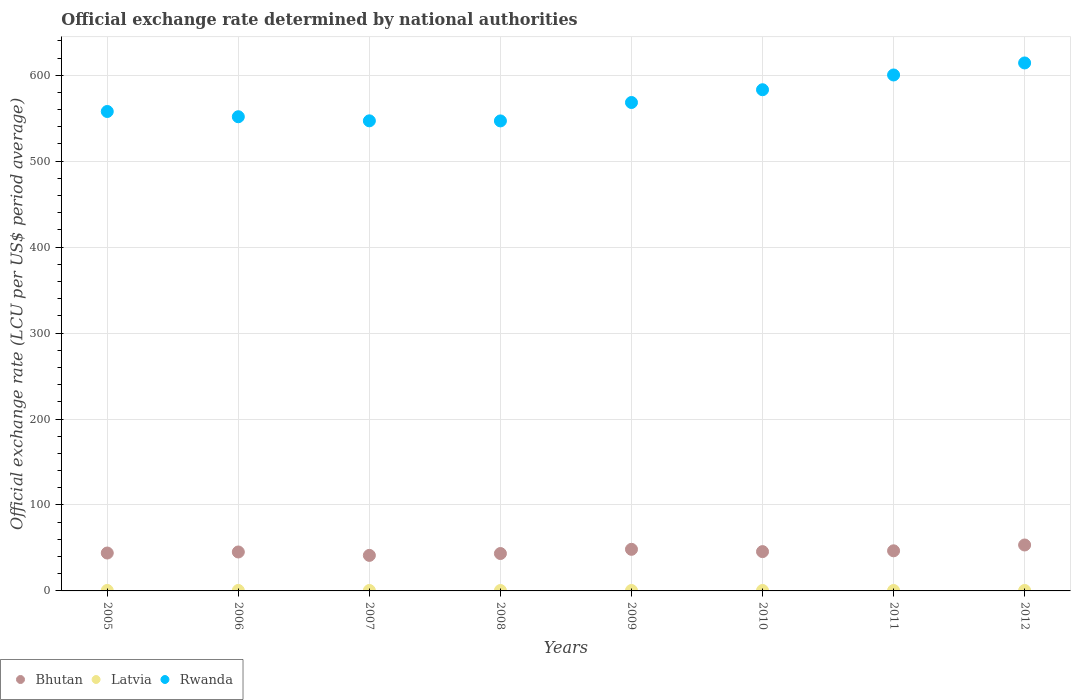How many different coloured dotlines are there?
Give a very brief answer. 3. Is the number of dotlines equal to the number of legend labels?
Ensure brevity in your answer.  Yes. What is the official exchange rate in Bhutan in 2007?
Your response must be concise. 41.35. Across all years, what is the maximum official exchange rate in Bhutan?
Offer a very short reply. 53.44. Across all years, what is the minimum official exchange rate in Rwanda?
Offer a terse response. 546.85. In which year was the official exchange rate in Rwanda minimum?
Keep it short and to the point. 2008. What is the total official exchange rate in Rwanda in the graph?
Provide a succinct answer. 4569.35. What is the difference between the official exchange rate in Rwanda in 2006 and that in 2009?
Provide a short and direct response. -16.57. What is the difference between the official exchange rate in Rwanda in 2011 and the official exchange rate in Latvia in 2012?
Offer a terse response. 599.76. What is the average official exchange rate in Bhutan per year?
Keep it short and to the point. 46.06. In the year 2008, what is the difference between the official exchange rate in Bhutan and official exchange rate in Latvia?
Your response must be concise. 43.02. In how many years, is the official exchange rate in Bhutan greater than 380 LCU?
Offer a very short reply. 0. What is the ratio of the official exchange rate in Latvia in 2005 to that in 2008?
Offer a terse response. 1.17. What is the difference between the highest and the second highest official exchange rate in Latvia?
Your response must be concise. 0. What is the difference between the highest and the lowest official exchange rate in Latvia?
Provide a succinct answer. 0.08. In how many years, is the official exchange rate in Bhutan greater than the average official exchange rate in Bhutan taken over all years?
Your answer should be compact. 3. Is the sum of the official exchange rate in Rwanda in 2008 and 2011 greater than the maximum official exchange rate in Bhutan across all years?
Give a very brief answer. Yes. Is it the case that in every year, the sum of the official exchange rate in Latvia and official exchange rate in Rwanda  is greater than the official exchange rate in Bhutan?
Make the answer very short. Yes. Does the official exchange rate in Rwanda monotonically increase over the years?
Provide a succinct answer. No. How many dotlines are there?
Provide a succinct answer. 3. How many years are there in the graph?
Give a very brief answer. 8. Are the values on the major ticks of Y-axis written in scientific E-notation?
Make the answer very short. No. Does the graph contain grids?
Your answer should be very brief. Yes. Where does the legend appear in the graph?
Provide a succinct answer. Bottom left. How are the legend labels stacked?
Your answer should be compact. Horizontal. What is the title of the graph?
Offer a terse response. Official exchange rate determined by national authorities. Does "Liberia" appear as one of the legend labels in the graph?
Make the answer very short. No. What is the label or title of the Y-axis?
Offer a terse response. Official exchange rate (LCU per US$ period average). What is the Official exchange rate (LCU per US$ period average) in Bhutan in 2005?
Provide a short and direct response. 44.1. What is the Official exchange rate (LCU per US$ period average) of Latvia in 2005?
Make the answer very short. 0.56. What is the Official exchange rate (LCU per US$ period average) of Rwanda in 2005?
Provide a succinct answer. 557.82. What is the Official exchange rate (LCU per US$ period average) in Bhutan in 2006?
Your answer should be very brief. 45.31. What is the Official exchange rate (LCU per US$ period average) of Latvia in 2006?
Make the answer very short. 0.56. What is the Official exchange rate (LCU per US$ period average) in Rwanda in 2006?
Ensure brevity in your answer.  551.71. What is the Official exchange rate (LCU per US$ period average) in Bhutan in 2007?
Offer a very short reply. 41.35. What is the Official exchange rate (LCU per US$ period average) of Latvia in 2007?
Offer a very short reply. 0.51. What is the Official exchange rate (LCU per US$ period average) of Rwanda in 2007?
Your answer should be very brief. 546.96. What is the Official exchange rate (LCU per US$ period average) in Bhutan in 2008?
Your answer should be compact. 43.51. What is the Official exchange rate (LCU per US$ period average) of Latvia in 2008?
Your answer should be very brief. 0.48. What is the Official exchange rate (LCU per US$ period average) in Rwanda in 2008?
Provide a succinct answer. 546.85. What is the Official exchange rate (LCU per US$ period average) of Bhutan in 2009?
Keep it short and to the point. 48.41. What is the Official exchange rate (LCU per US$ period average) of Latvia in 2009?
Offer a very short reply. 0.51. What is the Official exchange rate (LCU per US$ period average) in Rwanda in 2009?
Your answer should be very brief. 568.28. What is the Official exchange rate (LCU per US$ period average) in Bhutan in 2010?
Your answer should be very brief. 45.73. What is the Official exchange rate (LCU per US$ period average) in Latvia in 2010?
Ensure brevity in your answer.  0.53. What is the Official exchange rate (LCU per US$ period average) in Rwanda in 2010?
Offer a very short reply. 583.13. What is the Official exchange rate (LCU per US$ period average) of Bhutan in 2011?
Ensure brevity in your answer.  46.67. What is the Official exchange rate (LCU per US$ period average) in Latvia in 2011?
Your response must be concise. 0.5. What is the Official exchange rate (LCU per US$ period average) in Rwanda in 2011?
Provide a short and direct response. 600.31. What is the Official exchange rate (LCU per US$ period average) of Bhutan in 2012?
Ensure brevity in your answer.  53.44. What is the Official exchange rate (LCU per US$ period average) of Latvia in 2012?
Offer a terse response. 0.55. What is the Official exchange rate (LCU per US$ period average) in Rwanda in 2012?
Your answer should be compact. 614.3. Across all years, what is the maximum Official exchange rate (LCU per US$ period average) in Bhutan?
Your response must be concise. 53.44. Across all years, what is the maximum Official exchange rate (LCU per US$ period average) in Latvia?
Keep it short and to the point. 0.56. Across all years, what is the maximum Official exchange rate (LCU per US$ period average) of Rwanda?
Ensure brevity in your answer.  614.3. Across all years, what is the minimum Official exchange rate (LCU per US$ period average) in Bhutan?
Offer a terse response. 41.35. Across all years, what is the minimum Official exchange rate (LCU per US$ period average) in Latvia?
Your answer should be compact. 0.48. Across all years, what is the minimum Official exchange rate (LCU per US$ period average) of Rwanda?
Keep it short and to the point. 546.85. What is the total Official exchange rate (LCU per US$ period average) of Bhutan in the graph?
Provide a succinct answer. 368.5. What is the total Official exchange rate (LCU per US$ period average) of Latvia in the graph?
Keep it short and to the point. 4.2. What is the total Official exchange rate (LCU per US$ period average) in Rwanda in the graph?
Make the answer very short. 4569.35. What is the difference between the Official exchange rate (LCU per US$ period average) in Bhutan in 2005 and that in 2006?
Your response must be concise. -1.21. What is the difference between the Official exchange rate (LCU per US$ period average) of Latvia in 2005 and that in 2006?
Provide a short and direct response. 0. What is the difference between the Official exchange rate (LCU per US$ period average) of Rwanda in 2005 and that in 2006?
Offer a terse response. 6.11. What is the difference between the Official exchange rate (LCU per US$ period average) in Bhutan in 2005 and that in 2007?
Ensure brevity in your answer.  2.75. What is the difference between the Official exchange rate (LCU per US$ period average) in Latvia in 2005 and that in 2007?
Your response must be concise. 0.05. What is the difference between the Official exchange rate (LCU per US$ period average) in Rwanda in 2005 and that in 2007?
Give a very brief answer. 10.87. What is the difference between the Official exchange rate (LCU per US$ period average) of Bhutan in 2005 and that in 2008?
Your response must be concise. 0.59. What is the difference between the Official exchange rate (LCU per US$ period average) of Latvia in 2005 and that in 2008?
Provide a short and direct response. 0.08. What is the difference between the Official exchange rate (LCU per US$ period average) of Rwanda in 2005 and that in 2008?
Make the answer very short. 10.97. What is the difference between the Official exchange rate (LCU per US$ period average) of Bhutan in 2005 and that in 2009?
Ensure brevity in your answer.  -4.31. What is the difference between the Official exchange rate (LCU per US$ period average) of Latvia in 2005 and that in 2009?
Give a very brief answer. 0.06. What is the difference between the Official exchange rate (LCU per US$ period average) of Rwanda in 2005 and that in 2009?
Give a very brief answer. -10.46. What is the difference between the Official exchange rate (LCU per US$ period average) of Bhutan in 2005 and that in 2010?
Offer a very short reply. -1.63. What is the difference between the Official exchange rate (LCU per US$ period average) in Latvia in 2005 and that in 2010?
Ensure brevity in your answer.  0.03. What is the difference between the Official exchange rate (LCU per US$ period average) in Rwanda in 2005 and that in 2010?
Give a very brief answer. -25.31. What is the difference between the Official exchange rate (LCU per US$ period average) in Bhutan in 2005 and that in 2011?
Provide a succinct answer. -2.57. What is the difference between the Official exchange rate (LCU per US$ period average) in Latvia in 2005 and that in 2011?
Provide a short and direct response. 0.06. What is the difference between the Official exchange rate (LCU per US$ period average) in Rwanda in 2005 and that in 2011?
Make the answer very short. -42.48. What is the difference between the Official exchange rate (LCU per US$ period average) in Bhutan in 2005 and that in 2012?
Offer a very short reply. -9.34. What is the difference between the Official exchange rate (LCU per US$ period average) of Latvia in 2005 and that in 2012?
Your answer should be very brief. 0.02. What is the difference between the Official exchange rate (LCU per US$ period average) in Rwanda in 2005 and that in 2012?
Keep it short and to the point. -56.47. What is the difference between the Official exchange rate (LCU per US$ period average) of Bhutan in 2006 and that in 2007?
Your answer should be very brief. 3.96. What is the difference between the Official exchange rate (LCU per US$ period average) in Latvia in 2006 and that in 2007?
Make the answer very short. 0.05. What is the difference between the Official exchange rate (LCU per US$ period average) in Rwanda in 2006 and that in 2007?
Your answer should be compact. 4.76. What is the difference between the Official exchange rate (LCU per US$ period average) in Bhutan in 2006 and that in 2008?
Your answer should be very brief. 1.8. What is the difference between the Official exchange rate (LCU per US$ period average) of Latvia in 2006 and that in 2008?
Provide a short and direct response. 0.08. What is the difference between the Official exchange rate (LCU per US$ period average) in Rwanda in 2006 and that in 2008?
Your answer should be very brief. 4.86. What is the difference between the Official exchange rate (LCU per US$ period average) in Bhutan in 2006 and that in 2009?
Provide a succinct answer. -3.1. What is the difference between the Official exchange rate (LCU per US$ period average) of Latvia in 2006 and that in 2009?
Make the answer very short. 0.05. What is the difference between the Official exchange rate (LCU per US$ period average) of Rwanda in 2006 and that in 2009?
Keep it short and to the point. -16.57. What is the difference between the Official exchange rate (LCU per US$ period average) in Bhutan in 2006 and that in 2010?
Offer a terse response. -0.42. What is the difference between the Official exchange rate (LCU per US$ period average) in Latvia in 2006 and that in 2010?
Your answer should be compact. 0.03. What is the difference between the Official exchange rate (LCU per US$ period average) in Rwanda in 2006 and that in 2010?
Give a very brief answer. -31.42. What is the difference between the Official exchange rate (LCU per US$ period average) in Bhutan in 2006 and that in 2011?
Your response must be concise. -1.36. What is the difference between the Official exchange rate (LCU per US$ period average) in Latvia in 2006 and that in 2011?
Keep it short and to the point. 0.06. What is the difference between the Official exchange rate (LCU per US$ period average) in Rwanda in 2006 and that in 2011?
Your response must be concise. -48.6. What is the difference between the Official exchange rate (LCU per US$ period average) in Bhutan in 2006 and that in 2012?
Make the answer very short. -8.13. What is the difference between the Official exchange rate (LCU per US$ period average) of Latvia in 2006 and that in 2012?
Offer a terse response. 0.01. What is the difference between the Official exchange rate (LCU per US$ period average) of Rwanda in 2006 and that in 2012?
Make the answer very short. -62.58. What is the difference between the Official exchange rate (LCU per US$ period average) in Bhutan in 2007 and that in 2008?
Your answer should be very brief. -2.16. What is the difference between the Official exchange rate (LCU per US$ period average) of Latvia in 2007 and that in 2008?
Offer a terse response. 0.03. What is the difference between the Official exchange rate (LCU per US$ period average) of Rwanda in 2007 and that in 2008?
Keep it short and to the point. 0.11. What is the difference between the Official exchange rate (LCU per US$ period average) in Bhutan in 2007 and that in 2009?
Ensure brevity in your answer.  -7.06. What is the difference between the Official exchange rate (LCU per US$ period average) of Latvia in 2007 and that in 2009?
Your answer should be very brief. 0.01. What is the difference between the Official exchange rate (LCU per US$ period average) of Rwanda in 2007 and that in 2009?
Your response must be concise. -21.33. What is the difference between the Official exchange rate (LCU per US$ period average) in Bhutan in 2007 and that in 2010?
Your answer should be compact. -4.38. What is the difference between the Official exchange rate (LCU per US$ period average) in Latvia in 2007 and that in 2010?
Offer a very short reply. -0.02. What is the difference between the Official exchange rate (LCU per US$ period average) in Rwanda in 2007 and that in 2010?
Keep it short and to the point. -36.18. What is the difference between the Official exchange rate (LCU per US$ period average) of Bhutan in 2007 and that in 2011?
Your answer should be compact. -5.32. What is the difference between the Official exchange rate (LCU per US$ period average) in Latvia in 2007 and that in 2011?
Make the answer very short. 0.01. What is the difference between the Official exchange rate (LCU per US$ period average) of Rwanda in 2007 and that in 2011?
Give a very brief answer. -53.35. What is the difference between the Official exchange rate (LCU per US$ period average) of Bhutan in 2007 and that in 2012?
Offer a terse response. -12.09. What is the difference between the Official exchange rate (LCU per US$ period average) in Latvia in 2007 and that in 2012?
Ensure brevity in your answer.  -0.03. What is the difference between the Official exchange rate (LCU per US$ period average) in Rwanda in 2007 and that in 2012?
Provide a short and direct response. -67.34. What is the difference between the Official exchange rate (LCU per US$ period average) in Bhutan in 2008 and that in 2009?
Give a very brief answer. -4.9. What is the difference between the Official exchange rate (LCU per US$ period average) in Latvia in 2008 and that in 2009?
Offer a terse response. -0.02. What is the difference between the Official exchange rate (LCU per US$ period average) in Rwanda in 2008 and that in 2009?
Provide a short and direct response. -21.43. What is the difference between the Official exchange rate (LCU per US$ period average) of Bhutan in 2008 and that in 2010?
Make the answer very short. -2.22. What is the difference between the Official exchange rate (LCU per US$ period average) in Latvia in 2008 and that in 2010?
Your answer should be compact. -0.05. What is the difference between the Official exchange rate (LCU per US$ period average) in Rwanda in 2008 and that in 2010?
Give a very brief answer. -36.28. What is the difference between the Official exchange rate (LCU per US$ period average) in Bhutan in 2008 and that in 2011?
Offer a very short reply. -3.17. What is the difference between the Official exchange rate (LCU per US$ period average) in Latvia in 2008 and that in 2011?
Ensure brevity in your answer.  -0.02. What is the difference between the Official exchange rate (LCU per US$ period average) in Rwanda in 2008 and that in 2011?
Your response must be concise. -53.46. What is the difference between the Official exchange rate (LCU per US$ period average) of Bhutan in 2008 and that in 2012?
Offer a very short reply. -9.93. What is the difference between the Official exchange rate (LCU per US$ period average) of Latvia in 2008 and that in 2012?
Ensure brevity in your answer.  -0.07. What is the difference between the Official exchange rate (LCU per US$ period average) in Rwanda in 2008 and that in 2012?
Keep it short and to the point. -67.45. What is the difference between the Official exchange rate (LCU per US$ period average) of Bhutan in 2009 and that in 2010?
Make the answer very short. 2.68. What is the difference between the Official exchange rate (LCU per US$ period average) in Latvia in 2009 and that in 2010?
Give a very brief answer. -0.02. What is the difference between the Official exchange rate (LCU per US$ period average) of Rwanda in 2009 and that in 2010?
Your response must be concise. -14.85. What is the difference between the Official exchange rate (LCU per US$ period average) in Bhutan in 2009 and that in 2011?
Provide a short and direct response. 1.73. What is the difference between the Official exchange rate (LCU per US$ period average) in Latvia in 2009 and that in 2011?
Provide a short and direct response. 0. What is the difference between the Official exchange rate (LCU per US$ period average) in Rwanda in 2009 and that in 2011?
Provide a succinct answer. -32.03. What is the difference between the Official exchange rate (LCU per US$ period average) of Bhutan in 2009 and that in 2012?
Offer a very short reply. -5.03. What is the difference between the Official exchange rate (LCU per US$ period average) in Latvia in 2009 and that in 2012?
Your response must be concise. -0.04. What is the difference between the Official exchange rate (LCU per US$ period average) in Rwanda in 2009 and that in 2012?
Offer a very short reply. -46.01. What is the difference between the Official exchange rate (LCU per US$ period average) of Bhutan in 2010 and that in 2011?
Give a very brief answer. -0.94. What is the difference between the Official exchange rate (LCU per US$ period average) in Latvia in 2010 and that in 2011?
Make the answer very short. 0.03. What is the difference between the Official exchange rate (LCU per US$ period average) of Rwanda in 2010 and that in 2011?
Make the answer very short. -17.18. What is the difference between the Official exchange rate (LCU per US$ period average) in Bhutan in 2010 and that in 2012?
Your response must be concise. -7.71. What is the difference between the Official exchange rate (LCU per US$ period average) of Latvia in 2010 and that in 2012?
Provide a succinct answer. -0.02. What is the difference between the Official exchange rate (LCU per US$ period average) in Rwanda in 2010 and that in 2012?
Keep it short and to the point. -31.16. What is the difference between the Official exchange rate (LCU per US$ period average) of Bhutan in 2011 and that in 2012?
Your response must be concise. -6.77. What is the difference between the Official exchange rate (LCU per US$ period average) in Latvia in 2011 and that in 2012?
Offer a terse response. -0.05. What is the difference between the Official exchange rate (LCU per US$ period average) in Rwanda in 2011 and that in 2012?
Ensure brevity in your answer.  -13.99. What is the difference between the Official exchange rate (LCU per US$ period average) of Bhutan in 2005 and the Official exchange rate (LCU per US$ period average) of Latvia in 2006?
Your answer should be very brief. 43.54. What is the difference between the Official exchange rate (LCU per US$ period average) of Bhutan in 2005 and the Official exchange rate (LCU per US$ period average) of Rwanda in 2006?
Offer a very short reply. -507.61. What is the difference between the Official exchange rate (LCU per US$ period average) in Latvia in 2005 and the Official exchange rate (LCU per US$ period average) in Rwanda in 2006?
Ensure brevity in your answer.  -551.15. What is the difference between the Official exchange rate (LCU per US$ period average) of Bhutan in 2005 and the Official exchange rate (LCU per US$ period average) of Latvia in 2007?
Offer a terse response. 43.59. What is the difference between the Official exchange rate (LCU per US$ period average) of Bhutan in 2005 and the Official exchange rate (LCU per US$ period average) of Rwanda in 2007?
Provide a succinct answer. -502.86. What is the difference between the Official exchange rate (LCU per US$ period average) in Latvia in 2005 and the Official exchange rate (LCU per US$ period average) in Rwanda in 2007?
Provide a succinct answer. -546.39. What is the difference between the Official exchange rate (LCU per US$ period average) in Bhutan in 2005 and the Official exchange rate (LCU per US$ period average) in Latvia in 2008?
Keep it short and to the point. 43.62. What is the difference between the Official exchange rate (LCU per US$ period average) in Bhutan in 2005 and the Official exchange rate (LCU per US$ period average) in Rwanda in 2008?
Ensure brevity in your answer.  -502.75. What is the difference between the Official exchange rate (LCU per US$ period average) of Latvia in 2005 and the Official exchange rate (LCU per US$ period average) of Rwanda in 2008?
Ensure brevity in your answer.  -546.28. What is the difference between the Official exchange rate (LCU per US$ period average) in Bhutan in 2005 and the Official exchange rate (LCU per US$ period average) in Latvia in 2009?
Keep it short and to the point. 43.59. What is the difference between the Official exchange rate (LCU per US$ period average) in Bhutan in 2005 and the Official exchange rate (LCU per US$ period average) in Rwanda in 2009?
Offer a terse response. -524.18. What is the difference between the Official exchange rate (LCU per US$ period average) of Latvia in 2005 and the Official exchange rate (LCU per US$ period average) of Rwanda in 2009?
Your response must be concise. -567.72. What is the difference between the Official exchange rate (LCU per US$ period average) of Bhutan in 2005 and the Official exchange rate (LCU per US$ period average) of Latvia in 2010?
Your response must be concise. 43.57. What is the difference between the Official exchange rate (LCU per US$ period average) of Bhutan in 2005 and the Official exchange rate (LCU per US$ period average) of Rwanda in 2010?
Offer a very short reply. -539.03. What is the difference between the Official exchange rate (LCU per US$ period average) in Latvia in 2005 and the Official exchange rate (LCU per US$ period average) in Rwanda in 2010?
Offer a very short reply. -582.57. What is the difference between the Official exchange rate (LCU per US$ period average) in Bhutan in 2005 and the Official exchange rate (LCU per US$ period average) in Latvia in 2011?
Provide a succinct answer. 43.6. What is the difference between the Official exchange rate (LCU per US$ period average) in Bhutan in 2005 and the Official exchange rate (LCU per US$ period average) in Rwanda in 2011?
Ensure brevity in your answer.  -556.21. What is the difference between the Official exchange rate (LCU per US$ period average) of Latvia in 2005 and the Official exchange rate (LCU per US$ period average) of Rwanda in 2011?
Keep it short and to the point. -599.74. What is the difference between the Official exchange rate (LCU per US$ period average) of Bhutan in 2005 and the Official exchange rate (LCU per US$ period average) of Latvia in 2012?
Your answer should be very brief. 43.55. What is the difference between the Official exchange rate (LCU per US$ period average) in Bhutan in 2005 and the Official exchange rate (LCU per US$ period average) in Rwanda in 2012?
Offer a very short reply. -570.2. What is the difference between the Official exchange rate (LCU per US$ period average) of Latvia in 2005 and the Official exchange rate (LCU per US$ period average) of Rwanda in 2012?
Provide a succinct answer. -613.73. What is the difference between the Official exchange rate (LCU per US$ period average) in Bhutan in 2006 and the Official exchange rate (LCU per US$ period average) in Latvia in 2007?
Your response must be concise. 44.79. What is the difference between the Official exchange rate (LCU per US$ period average) of Bhutan in 2006 and the Official exchange rate (LCU per US$ period average) of Rwanda in 2007?
Your answer should be very brief. -501.65. What is the difference between the Official exchange rate (LCU per US$ period average) in Latvia in 2006 and the Official exchange rate (LCU per US$ period average) in Rwanda in 2007?
Provide a short and direct response. -546.39. What is the difference between the Official exchange rate (LCU per US$ period average) of Bhutan in 2006 and the Official exchange rate (LCU per US$ period average) of Latvia in 2008?
Provide a succinct answer. 44.83. What is the difference between the Official exchange rate (LCU per US$ period average) in Bhutan in 2006 and the Official exchange rate (LCU per US$ period average) in Rwanda in 2008?
Offer a terse response. -501.54. What is the difference between the Official exchange rate (LCU per US$ period average) in Latvia in 2006 and the Official exchange rate (LCU per US$ period average) in Rwanda in 2008?
Keep it short and to the point. -546.29. What is the difference between the Official exchange rate (LCU per US$ period average) of Bhutan in 2006 and the Official exchange rate (LCU per US$ period average) of Latvia in 2009?
Keep it short and to the point. 44.8. What is the difference between the Official exchange rate (LCU per US$ period average) of Bhutan in 2006 and the Official exchange rate (LCU per US$ period average) of Rwanda in 2009?
Offer a terse response. -522.97. What is the difference between the Official exchange rate (LCU per US$ period average) in Latvia in 2006 and the Official exchange rate (LCU per US$ period average) in Rwanda in 2009?
Provide a succinct answer. -567.72. What is the difference between the Official exchange rate (LCU per US$ period average) of Bhutan in 2006 and the Official exchange rate (LCU per US$ period average) of Latvia in 2010?
Give a very brief answer. 44.78. What is the difference between the Official exchange rate (LCU per US$ period average) of Bhutan in 2006 and the Official exchange rate (LCU per US$ period average) of Rwanda in 2010?
Ensure brevity in your answer.  -537.82. What is the difference between the Official exchange rate (LCU per US$ period average) of Latvia in 2006 and the Official exchange rate (LCU per US$ period average) of Rwanda in 2010?
Offer a terse response. -582.57. What is the difference between the Official exchange rate (LCU per US$ period average) of Bhutan in 2006 and the Official exchange rate (LCU per US$ period average) of Latvia in 2011?
Offer a very short reply. 44.81. What is the difference between the Official exchange rate (LCU per US$ period average) in Bhutan in 2006 and the Official exchange rate (LCU per US$ period average) in Rwanda in 2011?
Your answer should be very brief. -555. What is the difference between the Official exchange rate (LCU per US$ period average) of Latvia in 2006 and the Official exchange rate (LCU per US$ period average) of Rwanda in 2011?
Offer a very short reply. -599.75. What is the difference between the Official exchange rate (LCU per US$ period average) in Bhutan in 2006 and the Official exchange rate (LCU per US$ period average) in Latvia in 2012?
Ensure brevity in your answer.  44.76. What is the difference between the Official exchange rate (LCU per US$ period average) of Bhutan in 2006 and the Official exchange rate (LCU per US$ period average) of Rwanda in 2012?
Provide a short and direct response. -568.99. What is the difference between the Official exchange rate (LCU per US$ period average) in Latvia in 2006 and the Official exchange rate (LCU per US$ period average) in Rwanda in 2012?
Your answer should be compact. -613.73. What is the difference between the Official exchange rate (LCU per US$ period average) in Bhutan in 2007 and the Official exchange rate (LCU per US$ period average) in Latvia in 2008?
Provide a short and direct response. 40.87. What is the difference between the Official exchange rate (LCU per US$ period average) of Bhutan in 2007 and the Official exchange rate (LCU per US$ period average) of Rwanda in 2008?
Provide a succinct answer. -505.5. What is the difference between the Official exchange rate (LCU per US$ period average) of Latvia in 2007 and the Official exchange rate (LCU per US$ period average) of Rwanda in 2008?
Ensure brevity in your answer.  -546.33. What is the difference between the Official exchange rate (LCU per US$ period average) of Bhutan in 2007 and the Official exchange rate (LCU per US$ period average) of Latvia in 2009?
Your answer should be very brief. 40.84. What is the difference between the Official exchange rate (LCU per US$ period average) of Bhutan in 2007 and the Official exchange rate (LCU per US$ period average) of Rwanda in 2009?
Offer a very short reply. -526.93. What is the difference between the Official exchange rate (LCU per US$ period average) in Latvia in 2007 and the Official exchange rate (LCU per US$ period average) in Rwanda in 2009?
Make the answer very short. -567.77. What is the difference between the Official exchange rate (LCU per US$ period average) of Bhutan in 2007 and the Official exchange rate (LCU per US$ period average) of Latvia in 2010?
Ensure brevity in your answer.  40.82. What is the difference between the Official exchange rate (LCU per US$ period average) of Bhutan in 2007 and the Official exchange rate (LCU per US$ period average) of Rwanda in 2010?
Keep it short and to the point. -541.78. What is the difference between the Official exchange rate (LCU per US$ period average) of Latvia in 2007 and the Official exchange rate (LCU per US$ period average) of Rwanda in 2010?
Offer a very short reply. -582.62. What is the difference between the Official exchange rate (LCU per US$ period average) of Bhutan in 2007 and the Official exchange rate (LCU per US$ period average) of Latvia in 2011?
Keep it short and to the point. 40.85. What is the difference between the Official exchange rate (LCU per US$ period average) of Bhutan in 2007 and the Official exchange rate (LCU per US$ period average) of Rwanda in 2011?
Your response must be concise. -558.96. What is the difference between the Official exchange rate (LCU per US$ period average) in Latvia in 2007 and the Official exchange rate (LCU per US$ period average) in Rwanda in 2011?
Your answer should be compact. -599.79. What is the difference between the Official exchange rate (LCU per US$ period average) of Bhutan in 2007 and the Official exchange rate (LCU per US$ period average) of Latvia in 2012?
Your answer should be very brief. 40.8. What is the difference between the Official exchange rate (LCU per US$ period average) in Bhutan in 2007 and the Official exchange rate (LCU per US$ period average) in Rwanda in 2012?
Provide a short and direct response. -572.95. What is the difference between the Official exchange rate (LCU per US$ period average) of Latvia in 2007 and the Official exchange rate (LCU per US$ period average) of Rwanda in 2012?
Provide a short and direct response. -613.78. What is the difference between the Official exchange rate (LCU per US$ period average) of Bhutan in 2008 and the Official exchange rate (LCU per US$ period average) of Latvia in 2009?
Provide a succinct answer. 43. What is the difference between the Official exchange rate (LCU per US$ period average) in Bhutan in 2008 and the Official exchange rate (LCU per US$ period average) in Rwanda in 2009?
Offer a very short reply. -524.78. What is the difference between the Official exchange rate (LCU per US$ period average) of Latvia in 2008 and the Official exchange rate (LCU per US$ period average) of Rwanda in 2009?
Your answer should be compact. -567.8. What is the difference between the Official exchange rate (LCU per US$ period average) in Bhutan in 2008 and the Official exchange rate (LCU per US$ period average) in Latvia in 2010?
Make the answer very short. 42.97. What is the difference between the Official exchange rate (LCU per US$ period average) of Bhutan in 2008 and the Official exchange rate (LCU per US$ period average) of Rwanda in 2010?
Your answer should be very brief. -539.63. What is the difference between the Official exchange rate (LCU per US$ period average) of Latvia in 2008 and the Official exchange rate (LCU per US$ period average) of Rwanda in 2010?
Your answer should be compact. -582.65. What is the difference between the Official exchange rate (LCU per US$ period average) of Bhutan in 2008 and the Official exchange rate (LCU per US$ period average) of Latvia in 2011?
Your answer should be compact. 43. What is the difference between the Official exchange rate (LCU per US$ period average) of Bhutan in 2008 and the Official exchange rate (LCU per US$ period average) of Rwanda in 2011?
Provide a succinct answer. -556.8. What is the difference between the Official exchange rate (LCU per US$ period average) of Latvia in 2008 and the Official exchange rate (LCU per US$ period average) of Rwanda in 2011?
Provide a succinct answer. -599.83. What is the difference between the Official exchange rate (LCU per US$ period average) of Bhutan in 2008 and the Official exchange rate (LCU per US$ period average) of Latvia in 2012?
Keep it short and to the point. 42.96. What is the difference between the Official exchange rate (LCU per US$ period average) of Bhutan in 2008 and the Official exchange rate (LCU per US$ period average) of Rwanda in 2012?
Provide a succinct answer. -570.79. What is the difference between the Official exchange rate (LCU per US$ period average) of Latvia in 2008 and the Official exchange rate (LCU per US$ period average) of Rwanda in 2012?
Keep it short and to the point. -613.81. What is the difference between the Official exchange rate (LCU per US$ period average) in Bhutan in 2009 and the Official exchange rate (LCU per US$ period average) in Latvia in 2010?
Make the answer very short. 47.87. What is the difference between the Official exchange rate (LCU per US$ period average) in Bhutan in 2009 and the Official exchange rate (LCU per US$ period average) in Rwanda in 2010?
Offer a terse response. -534.73. What is the difference between the Official exchange rate (LCU per US$ period average) of Latvia in 2009 and the Official exchange rate (LCU per US$ period average) of Rwanda in 2010?
Ensure brevity in your answer.  -582.63. What is the difference between the Official exchange rate (LCU per US$ period average) of Bhutan in 2009 and the Official exchange rate (LCU per US$ period average) of Latvia in 2011?
Your response must be concise. 47.9. What is the difference between the Official exchange rate (LCU per US$ period average) of Bhutan in 2009 and the Official exchange rate (LCU per US$ period average) of Rwanda in 2011?
Keep it short and to the point. -551.9. What is the difference between the Official exchange rate (LCU per US$ period average) in Latvia in 2009 and the Official exchange rate (LCU per US$ period average) in Rwanda in 2011?
Your response must be concise. -599.8. What is the difference between the Official exchange rate (LCU per US$ period average) of Bhutan in 2009 and the Official exchange rate (LCU per US$ period average) of Latvia in 2012?
Your answer should be compact. 47.86. What is the difference between the Official exchange rate (LCU per US$ period average) of Bhutan in 2009 and the Official exchange rate (LCU per US$ period average) of Rwanda in 2012?
Your response must be concise. -565.89. What is the difference between the Official exchange rate (LCU per US$ period average) of Latvia in 2009 and the Official exchange rate (LCU per US$ period average) of Rwanda in 2012?
Provide a short and direct response. -613.79. What is the difference between the Official exchange rate (LCU per US$ period average) of Bhutan in 2010 and the Official exchange rate (LCU per US$ period average) of Latvia in 2011?
Provide a succinct answer. 45.22. What is the difference between the Official exchange rate (LCU per US$ period average) in Bhutan in 2010 and the Official exchange rate (LCU per US$ period average) in Rwanda in 2011?
Your answer should be compact. -554.58. What is the difference between the Official exchange rate (LCU per US$ period average) in Latvia in 2010 and the Official exchange rate (LCU per US$ period average) in Rwanda in 2011?
Your answer should be very brief. -599.78. What is the difference between the Official exchange rate (LCU per US$ period average) of Bhutan in 2010 and the Official exchange rate (LCU per US$ period average) of Latvia in 2012?
Your response must be concise. 45.18. What is the difference between the Official exchange rate (LCU per US$ period average) of Bhutan in 2010 and the Official exchange rate (LCU per US$ period average) of Rwanda in 2012?
Your response must be concise. -568.57. What is the difference between the Official exchange rate (LCU per US$ period average) of Latvia in 2010 and the Official exchange rate (LCU per US$ period average) of Rwanda in 2012?
Ensure brevity in your answer.  -613.76. What is the difference between the Official exchange rate (LCU per US$ period average) of Bhutan in 2011 and the Official exchange rate (LCU per US$ period average) of Latvia in 2012?
Provide a short and direct response. 46.12. What is the difference between the Official exchange rate (LCU per US$ period average) of Bhutan in 2011 and the Official exchange rate (LCU per US$ period average) of Rwanda in 2012?
Provide a short and direct response. -567.62. What is the difference between the Official exchange rate (LCU per US$ period average) in Latvia in 2011 and the Official exchange rate (LCU per US$ period average) in Rwanda in 2012?
Your response must be concise. -613.79. What is the average Official exchange rate (LCU per US$ period average) in Bhutan per year?
Ensure brevity in your answer.  46.06. What is the average Official exchange rate (LCU per US$ period average) in Latvia per year?
Your answer should be compact. 0.53. What is the average Official exchange rate (LCU per US$ period average) in Rwanda per year?
Offer a very short reply. 571.17. In the year 2005, what is the difference between the Official exchange rate (LCU per US$ period average) in Bhutan and Official exchange rate (LCU per US$ period average) in Latvia?
Provide a short and direct response. 43.54. In the year 2005, what is the difference between the Official exchange rate (LCU per US$ period average) in Bhutan and Official exchange rate (LCU per US$ period average) in Rwanda?
Offer a very short reply. -513.72. In the year 2005, what is the difference between the Official exchange rate (LCU per US$ period average) of Latvia and Official exchange rate (LCU per US$ period average) of Rwanda?
Offer a terse response. -557.26. In the year 2006, what is the difference between the Official exchange rate (LCU per US$ period average) of Bhutan and Official exchange rate (LCU per US$ period average) of Latvia?
Offer a very short reply. 44.75. In the year 2006, what is the difference between the Official exchange rate (LCU per US$ period average) of Bhutan and Official exchange rate (LCU per US$ period average) of Rwanda?
Your answer should be compact. -506.4. In the year 2006, what is the difference between the Official exchange rate (LCU per US$ period average) of Latvia and Official exchange rate (LCU per US$ period average) of Rwanda?
Provide a succinct answer. -551.15. In the year 2007, what is the difference between the Official exchange rate (LCU per US$ period average) in Bhutan and Official exchange rate (LCU per US$ period average) in Latvia?
Provide a succinct answer. 40.83. In the year 2007, what is the difference between the Official exchange rate (LCU per US$ period average) of Bhutan and Official exchange rate (LCU per US$ period average) of Rwanda?
Give a very brief answer. -505.61. In the year 2007, what is the difference between the Official exchange rate (LCU per US$ period average) of Latvia and Official exchange rate (LCU per US$ period average) of Rwanda?
Provide a short and direct response. -546.44. In the year 2008, what is the difference between the Official exchange rate (LCU per US$ period average) of Bhutan and Official exchange rate (LCU per US$ period average) of Latvia?
Offer a very short reply. 43.02. In the year 2008, what is the difference between the Official exchange rate (LCU per US$ period average) of Bhutan and Official exchange rate (LCU per US$ period average) of Rwanda?
Provide a succinct answer. -503.34. In the year 2008, what is the difference between the Official exchange rate (LCU per US$ period average) in Latvia and Official exchange rate (LCU per US$ period average) in Rwanda?
Give a very brief answer. -546.37. In the year 2009, what is the difference between the Official exchange rate (LCU per US$ period average) in Bhutan and Official exchange rate (LCU per US$ period average) in Latvia?
Provide a short and direct response. 47.9. In the year 2009, what is the difference between the Official exchange rate (LCU per US$ period average) in Bhutan and Official exchange rate (LCU per US$ period average) in Rwanda?
Your response must be concise. -519.88. In the year 2009, what is the difference between the Official exchange rate (LCU per US$ period average) in Latvia and Official exchange rate (LCU per US$ period average) in Rwanda?
Your answer should be compact. -567.78. In the year 2010, what is the difference between the Official exchange rate (LCU per US$ period average) in Bhutan and Official exchange rate (LCU per US$ period average) in Latvia?
Make the answer very short. 45.2. In the year 2010, what is the difference between the Official exchange rate (LCU per US$ period average) of Bhutan and Official exchange rate (LCU per US$ period average) of Rwanda?
Your answer should be very brief. -537.41. In the year 2010, what is the difference between the Official exchange rate (LCU per US$ period average) in Latvia and Official exchange rate (LCU per US$ period average) in Rwanda?
Your answer should be compact. -582.6. In the year 2011, what is the difference between the Official exchange rate (LCU per US$ period average) of Bhutan and Official exchange rate (LCU per US$ period average) of Latvia?
Provide a short and direct response. 46.17. In the year 2011, what is the difference between the Official exchange rate (LCU per US$ period average) of Bhutan and Official exchange rate (LCU per US$ period average) of Rwanda?
Make the answer very short. -553.64. In the year 2011, what is the difference between the Official exchange rate (LCU per US$ period average) of Latvia and Official exchange rate (LCU per US$ period average) of Rwanda?
Give a very brief answer. -599.81. In the year 2012, what is the difference between the Official exchange rate (LCU per US$ period average) of Bhutan and Official exchange rate (LCU per US$ period average) of Latvia?
Offer a terse response. 52.89. In the year 2012, what is the difference between the Official exchange rate (LCU per US$ period average) of Bhutan and Official exchange rate (LCU per US$ period average) of Rwanda?
Offer a terse response. -560.86. In the year 2012, what is the difference between the Official exchange rate (LCU per US$ period average) of Latvia and Official exchange rate (LCU per US$ period average) of Rwanda?
Keep it short and to the point. -613.75. What is the ratio of the Official exchange rate (LCU per US$ period average) in Bhutan in 2005 to that in 2006?
Provide a short and direct response. 0.97. What is the ratio of the Official exchange rate (LCU per US$ period average) in Latvia in 2005 to that in 2006?
Give a very brief answer. 1.01. What is the ratio of the Official exchange rate (LCU per US$ period average) of Rwanda in 2005 to that in 2006?
Offer a very short reply. 1.01. What is the ratio of the Official exchange rate (LCU per US$ period average) in Bhutan in 2005 to that in 2007?
Provide a short and direct response. 1.07. What is the ratio of the Official exchange rate (LCU per US$ period average) in Latvia in 2005 to that in 2007?
Keep it short and to the point. 1.1. What is the ratio of the Official exchange rate (LCU per US$ period average) of Rwanda in 2005 to that in 2007?
Give a very brief answer. 1.02. What is the ratio of the Official exchange rate (LCU per US$ period average) in Bhutan in 2005 to that in 2008?
Ensure brevity in your answer.  1.01. What is the ratio of the Official exchange rate (LCU per US$ period average) of Latvia in 2005 to that in 2008?
Keep it short and to the point. 1.17. What is the ratio of the Official exchange rate (LCU per US$ period average) in Rwanda in 2005 to that in 2008?
Your answer should be very brief. 1.02. What is the ratio of the Official exchange rate (LCU per US$ period average) of Bhutan in 2005 to that in 2009?
Offer a terse response. 0.91. What is the ratio of the Official exchange rate (LCU per US$ period average) in Latvia in 2005 to that in 2009?
Your answer should be very brief. 1.12. What is the ratio of the Official exchange rate (LCU per US$ period average) in Rwanda in 2005 to that in 2009?
Provide a succinct answer. 0.98. What is the ratio of the Official exchange rate (LCU per US$ period average) in Bhutan in 2005 to that in 2010?
Offer a terse response. 0.96. What is the ratio of the Official exchange rate (LCU per US$ period average) of Latvia in 2005 to that in 2010?
Offer a very short reply. 1.06. What is the ratio of the Official exchange rate (LCU per US$ period average) of Rwanda in 2005 to that in 2010?
Give a very brief answer. 0.96. What is the ratio of the Official exchange rate (LCU per US$ period average) of Bhutan in 2005 to that in 2011?
Your answer should be very brief. 0.94. What is the ratio of the Official exchange rate (LCU per US$ period average) in Latvia in 2005 to that in 2011?
Ensure brevity in your answer.  1.13. What is the ratio of the Official exchange rate (LCU per US$ period average) of Rwanda in 2005 to that in 2011?
Provide a short and direct response. 0.93. What is the ratio of the Official exchange rate (LCU per US$ period average) in Bhutan in 2005 to that in 2012?
Offer a very short reply. 0.83. What is the ratio of the Official exchange rate (LCU per US$ period average) of Latvia in 2005 to that in 2012?
Your answer should be very brief. 1.03. What is the ratio of the Official exchange rate (LCU per US$ period average) of Rwanda in 2005 to that in 2012?
Give a very brief answer. 0.91. What is the ratio of the Official exchange rate (LCU per US$ period average) of Bhutan in 2006 to that in 2007?
Ensure brevity in your answer.  1.1. What is the ratio of the Official exchange rate (LCU per US$ period average) in Latvia in 2006 to that in 2007?
Provide a succinct answer. 1.09. What is the ratio of the Official exchange rate (LCU per US$ period average) of Rwanda in 2006 to that in 2007?
Your response must be concise. 1.01. What is the ratio of the Official exchange rate (LCU per US$ period average) of Bhutan in 2006 to that in 2008?
Keep it short and to the point. 1.04. What is the ratio of the Official exchange rate (LCU per US$ period average) in Latvia in 2006 to that in 2008?
Provide a short and direct response. 1.17. What is the ratio of the Official exchange rate (LCU per US$ period average) in Rwanda in 2006 to that in 2008?
Make the answer very short. 1.01. What is the ratio of the Official exchange rate (LCU per US$ period average) of Bhutan in 2006 to that in 2009?
Provide a succinct answer. 0.94. What is the ratio of the Official exchange rate (LCU per US$ period average) of Latvia in 2006 to that in 2009?
Provide a succinct answer. 1.11. What is the ratio of the Official exchange rate (LCU per US$ period average) in Rwanda in 2006 to that in 2009?
Your answer should be very brief. 0.97. What is the ratio of the Official exchange rate (LCU per US$ period average) of Latvia in 2006 to that in 2010?
Keep it short and to the point. 1.06. What is the ratio of the Official exchange rate (LCU per US$ period average) in Rwanda in 2006 to that in 2010?
Keep it short and to the point. 0.95. What is the ratio of the Official exchange rate (LCU per US$ period average) in Bhutan in 2006 to that in 2011?
Your answer should be very brief. 0.97. What is the ratio of the Official exchange rate (LCU per US$ period average) in Latvia in 2006 to that in 2011?
Your response must be concise. 1.12. What is the ratio of the Official exchange rate (LCU per US$ period average) in Rwanda in 2006 to that in 2011?
Make the answer very short. 0.92. What is the ratio of the Official exchange rate (LCU per US$ period average) of Bhutan in 2006 to that in 2012?
Offer a terse response. 0.85. What is the ratio of the Official exchange rate (LCU per US$ period average) of Latvia in 2006 to that in 2012?
Make the answer very short. 1.02. What is the ratio of the Official exchange rate (LCU per US$ period average) of Rwanda in 2006 to that in 2012?
Make the answer very short. 0.9. What is the ratio of the Official exchange rate (LCU per US$ period average) in Bhutan in 2007 to that in 2008?
Your answer should be compact. 0.95. What is the ratio of the Official exchange rate (LCU per US$ period average) in Latvia in 2007 to that in 2008?
Ensure brevity in your answer.  1.07. What is the ratio of the Official exchange rate (LCU per US$ period average) in Rwanda in 2007 to that in 2008?
Your answer should be very brief. 1. What is the ratio of the Official exchange rate (LCU per US$ period average) in Bhutan in 2007 to that in 2009?
Provide a short and direct response. 0.85. What is the ratio of the Official exchange rate (LCU per US$ period average) of Latvia in 2007 to that in 2009?
Your answer should be compact. 1.02. What is the ratio of the Official exchange rate (LCU per US$ period average) of Rwanda in 2007 to that in 2009?
Make the answer very short. 0.96. What is the ratio of the Official exchange rate (LCU per US$ period average) of Bhutan in 2007 to that in 2010?
Your answer should be very brief. 0.9. What is the ratio of the Official exchange rate (LCU per US$ period average) in Latvia in 2007 to that in 2010?
Offer a terse response. 0.97. What is the ratio of the Official exchange rate (LCU per US$ period average) of Rwanda in 2007 to that in 2010?
Ensure brevity in your answer.  0.94. What is the ratio of the Official exchange rate (LCU per US$ period average) of Bhutan in 2007 to that in 2011?
Offer a terse response. 0.89. What is the ratio of the Official exchange rate (LCU per US$ period average) in Latvia in 2007 to that in 2011?
Your response must be concise. 1.03. What is the ratio of the Official exchange rate (LCU per US$ period average) of Rwanda in 2007 to that in 2011?
Your response must be concise. 0.91. What is the ratio of the Official exchange rate (LCU per US$ period average) in Bhutan in 2007 to that in 2012?
Give a very brief answer. 0.77. What is the ratio of the Official exchange rate (LCU per US$ period average) of Latvia in 2007 to that in 2012?
Offer a very short reply. 0.94. What is the ratio of the Official exchange rate (LCU per US$ period average) in Rwanda in 2007 to that in 2012?
Offer a terse response. 0.89. What is the ratio of the Official exchange rate (LCU per US$ period average) in Bhutan in 2008 to that in 2009?
Your answer should be very brief. 0.9. What is the ratio of the Official exchange rate (LCU per US$ period average) in Latvia in 2008 to that in 2009?
Ensure brevity in your answer.  0.95. What is the ratio of the Official exchange rate (LCU per US$ period average) of Rwanda in 2008 to that in 2009?
Ensure brevity in your answer.  0.96. What is the ratio of the Official exchange rate (LCU per US$ period average) of Bhutan in 2008 to that in 2010?
Keep it short and to the point. 0.95. What is the ratio of the Official exchange rate (LCU per US$ period average) of Latvia in 2008 to that in 2010?
Your response must be concise. 0.91. What is the ratio of the Official exchange rate (LCU per US$ period average) of Rwanda in 2008 to that in 2010?
Ensure brevity in your answer.  0.94. What is the ratio of the Official exchange rate (LCU per US$ period average) of Bhutan in 2008 to that in 2011?
Provide a short and direct response. 0.93. What is the ratio of the Official exchange rate (LCU per US$ period average) in Latvia in 2008 to that in 2011?
Provide a succinct answer. 0.96. What is the ratio of the Official exchange rate (LCU per US$ period average) of Rwanda in 2008 to that in 2011?
Offer a very short reply. 0.91. What is the ratio of the Official exchange rate (LCU per US$ period average) in Bhutan in 2008 to that in 2012?
Provide a short and direct response. 0.81. What is the ratio of the Official exchange rate (LCU per US$ period average) in Latvia in 2008 to that in 2012?
Offer a very short reply. 0.88. What is the ratio of the Official exchange rate (LCU per US$ period average) of Rwanda in 2008 to that in 2012?
Provide a short and direct response. 0.89. What is the ratio of the Official exchange rate (LCU per US$ period average) in Bhutan in 2009 to that in 2010?
Give a very brief answer. 1.06. What is the ratio of the Official exchange rate (LCU per US$ period average) in Latvia in 2009 to that in 2010?
Provide a succinct answer. 0.95. What is the ratio of the Official exchange rate (LCU per US$ period average) in Rwanda in 2009 to that in 2010?
Give a very brief answer. 0.97. What is the ratio of the Official exchange rate (LCU per US$ period average) of Bhutan in 2009 to that in 2011?
Provide a short and direct response. 1.04. What is the ratio of the Official exchange rate (LCU per US$ period average) of Latvia in 2009 to that in 2011?
Provide a succinct answer. 1.01. What is the ratio of the Official exchange rate (LCU per US$ period average) of Rwanda in 2009 to that in 2011?
Make the answer very short. 0.95. What is the ratio of the Official exchange rate (LCU per US$ period average) of Bhutan in 2009 to that in 2012?
Make the answer very short. 0.91. What is the ratio of the Official exchange rate (LCU per US$ period average) in Latvia in 2009 to that in 2012?
Offer a terse response. 0.92. What is the ratio of the Official exchange rate (LCU per US$ period average) of Rwanda in 2009 to that in 2012?
Your response must be concise. 0.93. What is the ratio of the Official exchange rate (LCU per US$ period average) in Bhutan in 2010 to that in 2011?
Make the answer very short. 0.98. What is the ratio of the Official exchange rate (LCU per US$ period average) of Latvia in 2010 to that in 2011?
Your answer should be very brief. 1.06. What is the ratio of the Official exchange rate (LCU per US$ period average) of Rwanda in 2010 to that in 2011?
Ensure brevity in your answer.  0.97. What is the ratio of the Official exchange rate (LCU per US$ period average) of Bhutan in 2010 to that in 2012?
Ensure brevity in your answer.  0.86. What is the ratio of the Official exchange rate (LCU per US$ period average) of Latvia in 2010 to that in 2012?
Your answer should be very brief. 0.97. What is the ratio of the Official exchange rate (LCU per US$ period average) in Rwanda in 2010 to that in 2012?
Keep it short and to the point. 0.95. What is the ratio of the Official exchange rate (LCU per US$ period average) in Bhutan in 2011 to that in 2012?
Provide a short and direct response. 0.87. What is the ratio of the Official exchange rate (LCU per US$ period average) of Latvia in 2011 to that in 2012?
Your answer should be compact. 0.92. What is the ratio of the Official exchange rate (LCU per US$ period average) in Rwanda in 2011 to that in 2012?
Provide a succinct answer. 0.98. What is the difference between the highest and the second highest Official exchange rate (LCU per US$ period average) in Bhutan?
Give a very brief answer. 5.03. What is the difference between the highest and the second highest Official exchange rate (LCU per US$ period average) of Latvia?
Offer a terse response. 0. What is the difference between the highest and the second highest Official exchange rate (LCU per US$ period average) of Rwanda?
Keep it short and to the point. 13.99. What is the difference between the highest and the lowest Official exchange rate (LCU per US$ period average) in Bhutan?
Your answer should be very brief. 12.09. What is the difference between the highest and the lowest Official exchange rate (LCU per US$ period average) in Latvia?
Keep it short and to the point. 0.08. What is the difference between the highest and the lowest Official exchange rate (LCU per US$ period average) in Rwanda?
Give a very brief answer. 67.45. 